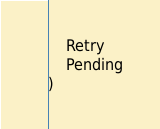Convert code to text. <code><loc_0><loc_0><loc_500><loc_500><_Go_>	Retry
	Pending
)
</code> 